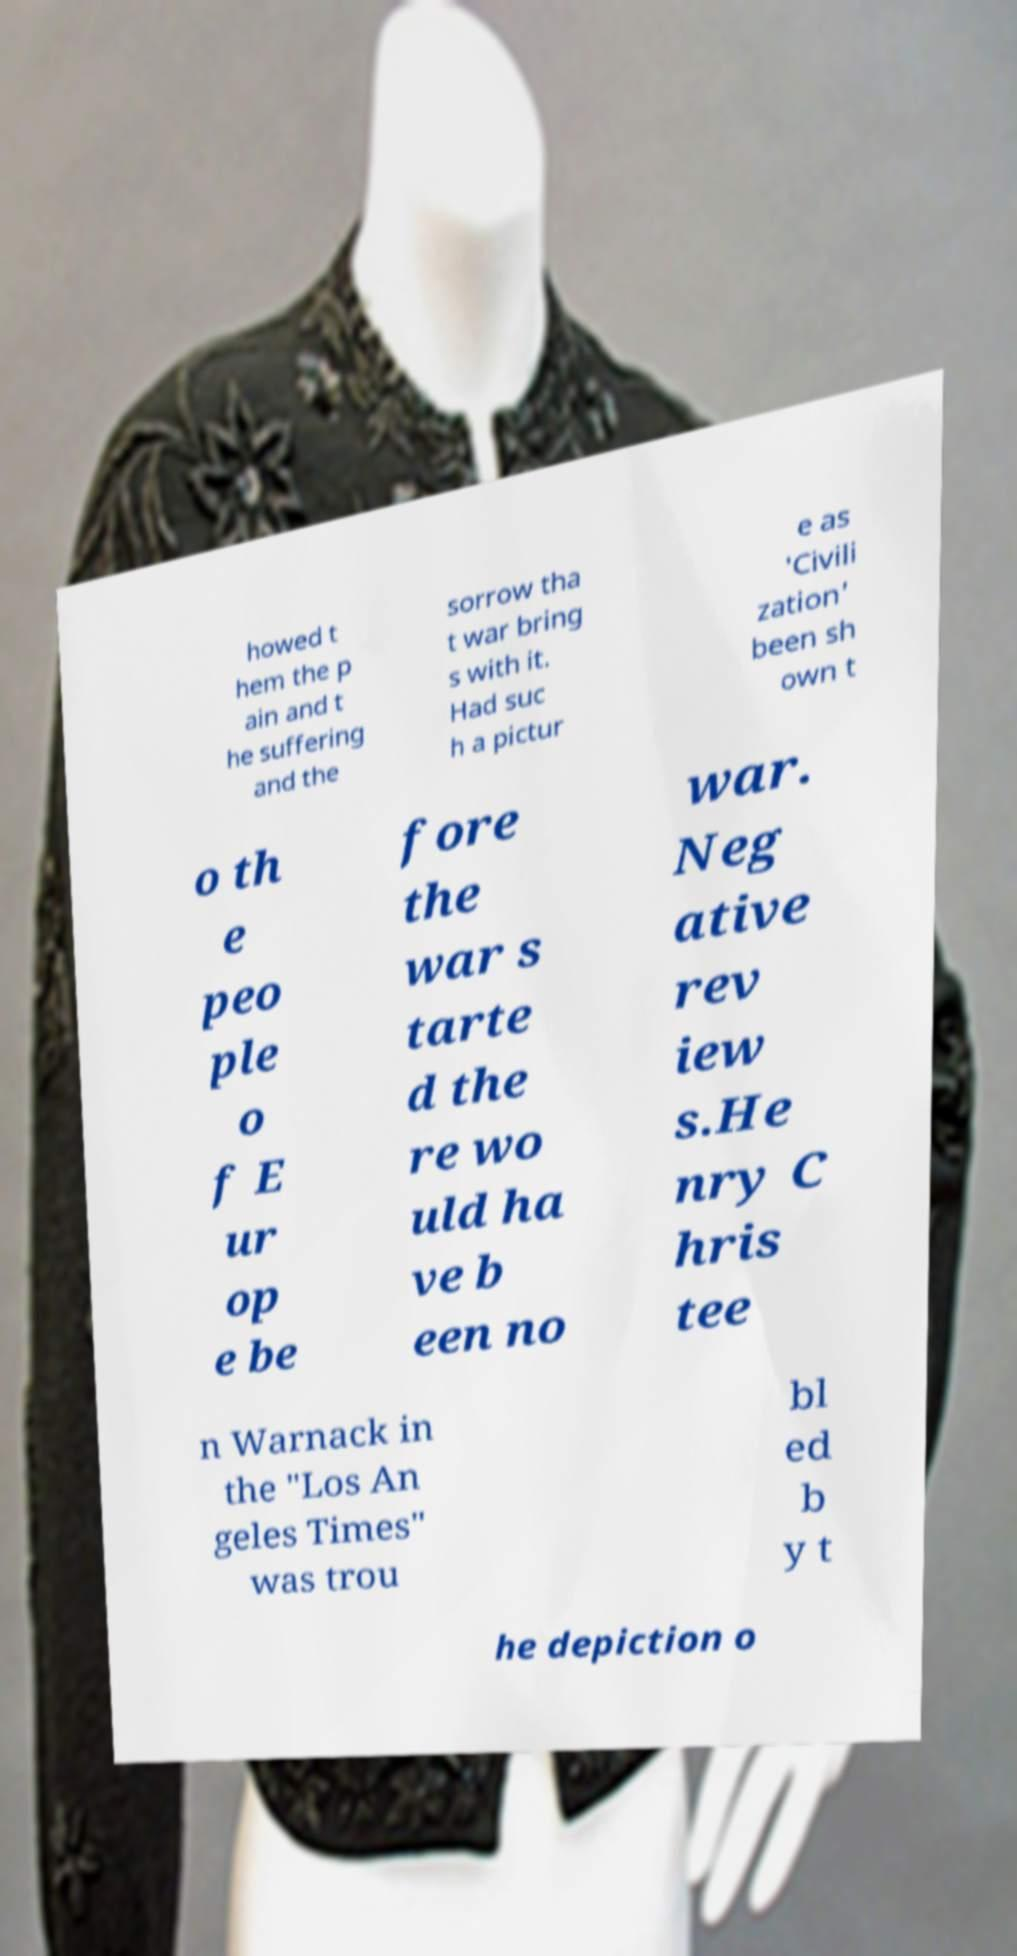Can you accurately transcribe the text from the provided image for me? howed t hem the p ain and t he suffering and the sorrow tha t war bring s with it. Had suc h a pictur e as 'Civili zation' been sh own t o th e peo ple o f E ur op e be fore the war s tarte d the re wo uld ha ve b een no war. Neg ative rev iew s.He nry C hris tee n Warnack in the "Los An geles Times" was trou bl ed b y t he depiction o 